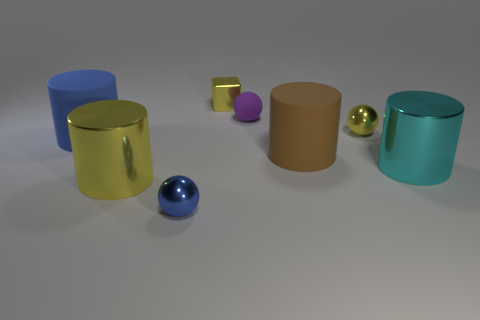Subtract all red cylinders. Subtract all cyan spheres. How many cylinders are left? 4 Add 2 yellow metallic cylinders. How many objects exist? 10 Subtract all cubes. How many objects are left? 7 Add 6 brown cylinders. How many brown cylinders are left? 7 Add 5 large yellow metallic objects. How many large yellow metallic objects exist? 6 Subtract 0 purple cylinders. How many objects are left? 8 Subtract all matte things. Subtract all large blue matte cylinders. How many objects are left? 4 